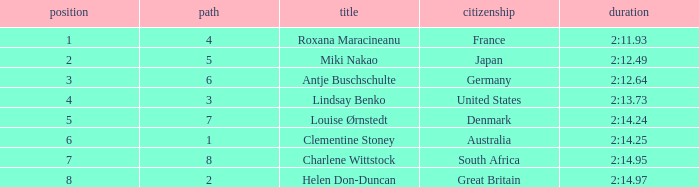What is the average Rank for a lane smaller than 3 with a nationality of Australia? 6.0. 